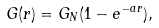Convert formula to latex. <formula><loc_0><loc_0><loc_500><loc_500>G ( r ) = G _ { N } ( 1 - e ^ { - a r } ) ,</formula> 